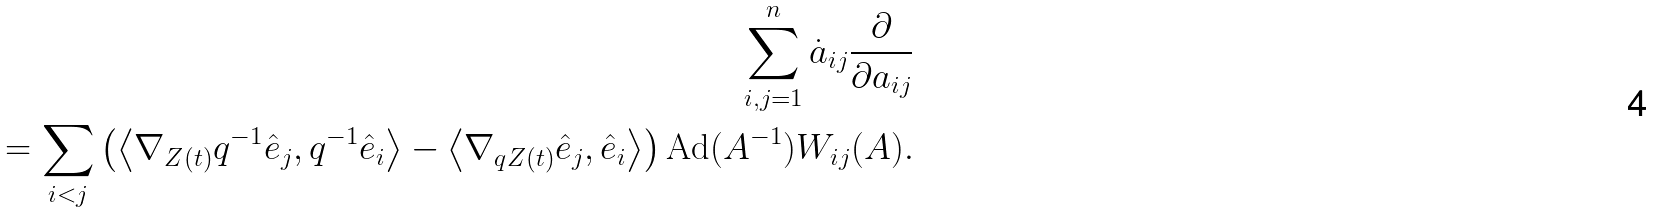<formula> <loc_0><loc_0><loc_500><loc_500>\sum _ { i , j = 1 } ^ { n } \dot { a } _ { i j } \frac { \partial } { \partial a _ { i j } } \\ = \sum _ { i < j } \left ( \left \langle \nabla _ { Z ( t ) } q ^ { - 1 } \hat { e } _ { j } , q ^ { - 1 } \hat { e } _ { i } \right \rangle - \left \langle \nabla _ { q Z ( t ) } \hat { e } _ { j } , \hat { e } _ { i } \right \rangle \right ) \text {Ad} ( A ^ { - 1 } ) W _ { i j } ( A ) .</formula> 